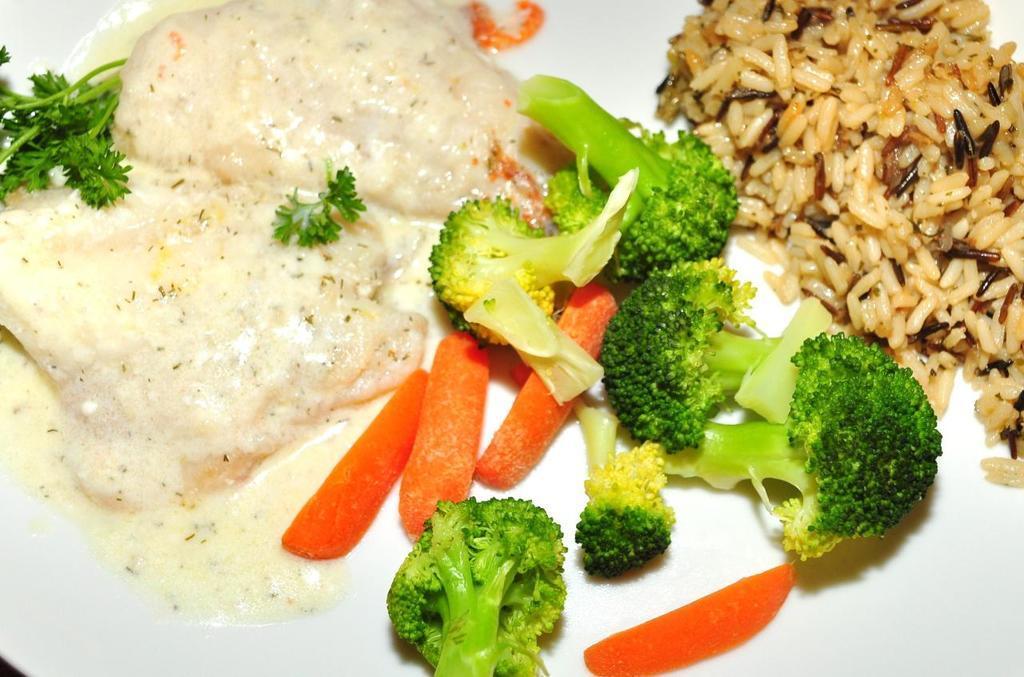In one or two sentences, can you explain what this image depicts? In this image there is a plate. On the plate there are few broccoli, carrots, rice, leafy vegetables and some food. 